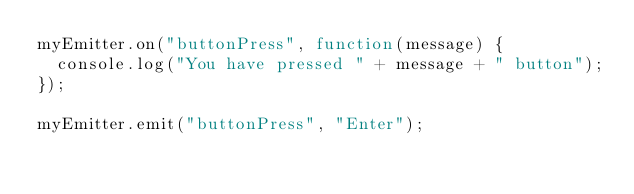<code> <loc_0><loc_0><loc_500><loc_500><_JavaScript_>myEmitter.on("buttonPress", function(message) {
  console.log("You have pressed " + message + " button");
});

myEmitter.emit("buttonPress", "Enter");
</code> 